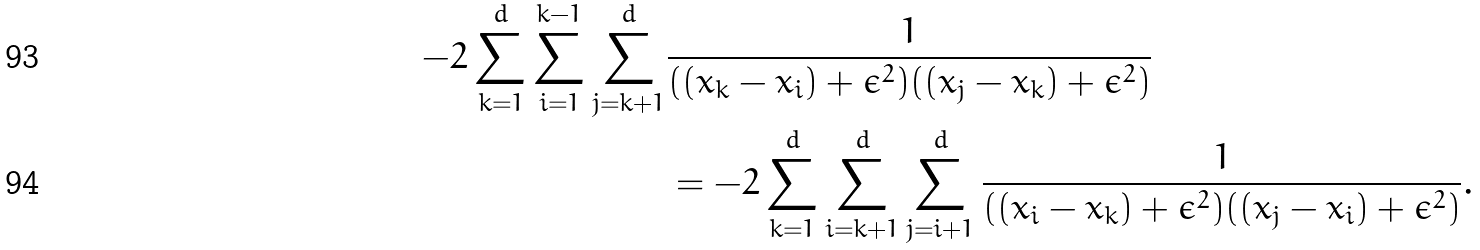Convert formula to latex. <formula><loc_0><loc_0><loc_500><loc_500>- 2 \sum _ { k = 1 } ^ { d } \sum _ { i = 1 } ^ { k - 1 } \sum _ { j = k + 1 } ^ { d } & \frac { 1 } { ( ( x _ { k } - x _ { i } ) + \epsilon ^ { 2 } ) ( ( x _ { j } - x _ { k } ) + \epsilon ^ { 2 } ) } \\ & = - 2 \sum _ { k = 1 } ^ { d } \sum _ { i = k + 1 } ^ { d } \sum _ { j = i + 1 } ^ { d } \frac { 1 } { ( ( x _ { i } - x _ { k } ) + \epsilon ^ { 2 } ) ( ( x _ { j } - x _ { i } ) + \epsilon ^ { 2 } ) } .</formula> 